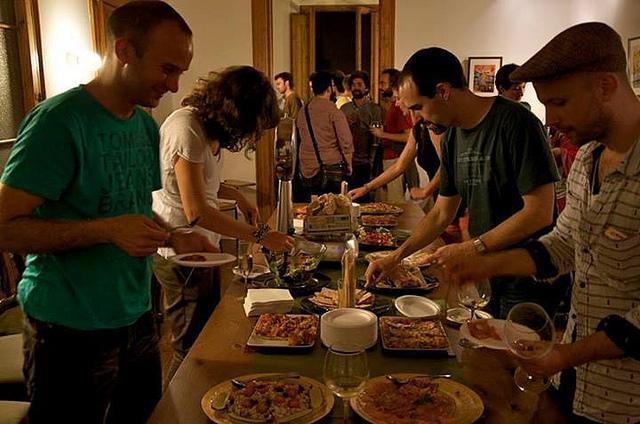How many people?
Give a very brief answer. 10. How many people are in the picture?
Give a very brief answer. 7. How many pizzas are in the picture?
Give a very brief answer. 2. How many wine glasses can be seen?
Give a very brief answer. 2. How many buses are solid blue?
Give a very brief answer. 0. 